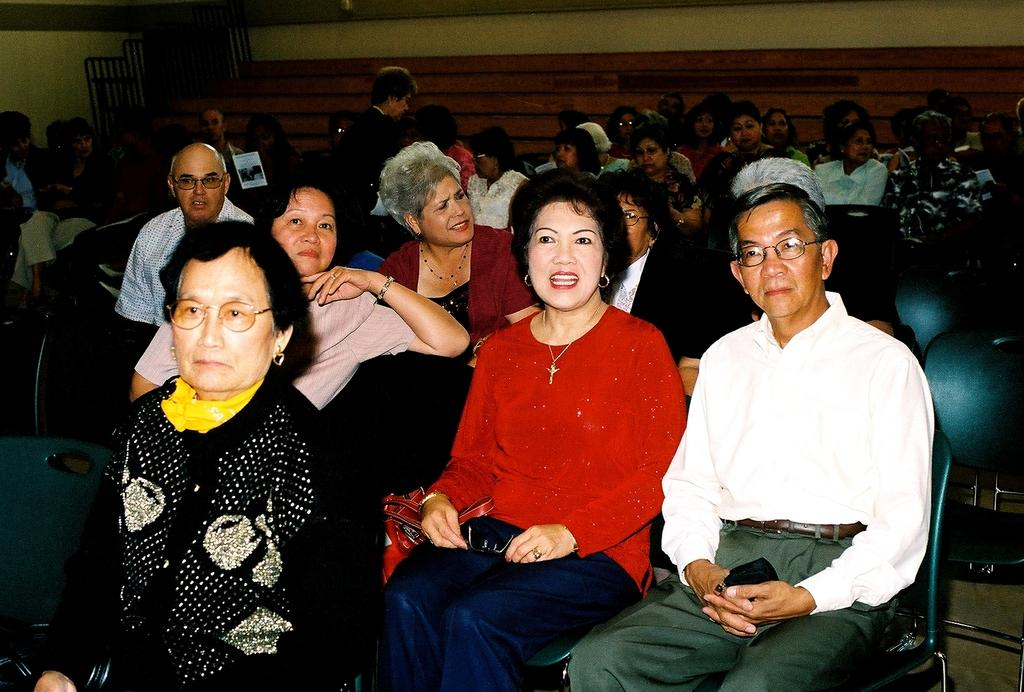How many people are present in the image? There are many people in the image. What are the people doing in the image? The people are sitting on chairs. Can you describe any accessories that some people are wearing? Some of the people are wearing glasses (specs). What can be seen in the background of the image? There is a wall in the background of the image. What type of iron can be seen on the beds in the image? There are no beds or irons present in the image; it features people sitting on chairs. 